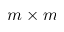Convert formula to latex. <formula><loc_0><loc_0><loc_500><loc_500>m \times m</formula> 